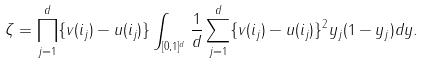<formula> <loc_0><loc_0><loc_500><loc_500>\zeta = \prod _ { j = 1 } ^ { d } \{ v ( i _ { j } ) - u ( i _ { j } ) \} \int _ { [ 0 , 1 ] ^ { d } } \frac { 1 } { d } \sum _ { j = 1 } ^ { d } \{ v ( i _ { j } ) - u ( i _ { j } ) \} ^ { 2 } y _ { j } ( 1 - y _ { j } ) d y .</formula> 